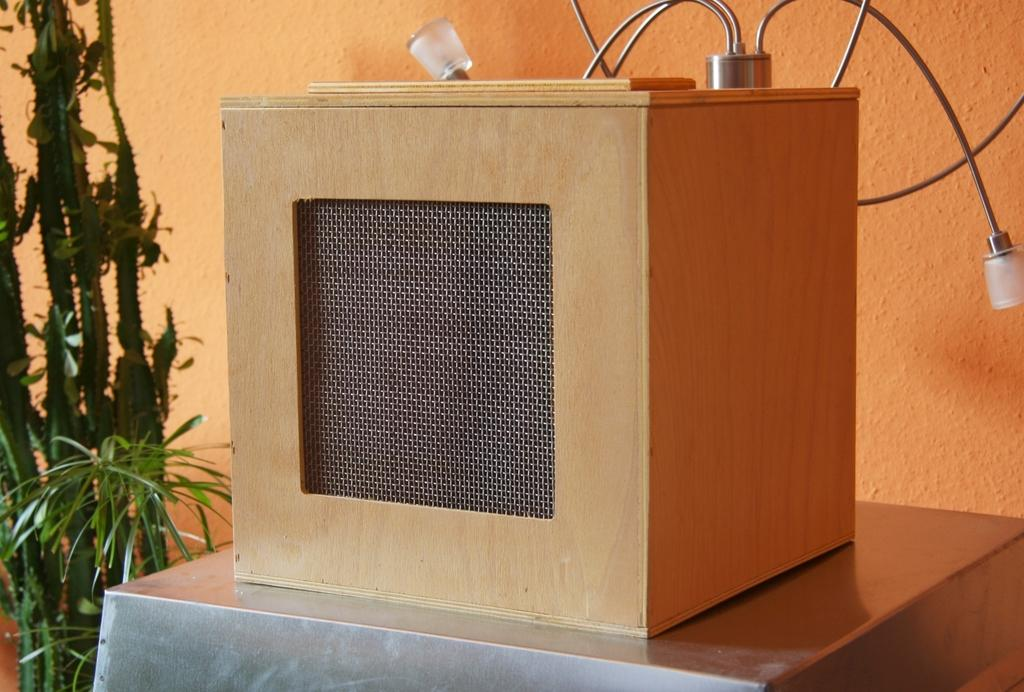What object is placed on the table in the image? There is a box placed on a table in the image. What type of living organisms can be seen in the image? Plants can be seen in the image. What type of watch is the man wearing in the image? There is no man or watch present in the image. How can we determine the level of noise in the image? The image does not provide any information about the noise level, as it only shows a box and plants. 